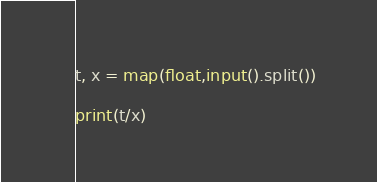<code> <loc_0><loc_0><loc_500><loc_500><_Python_>t, x = map(float,input().split())

print(t/x)</code> 